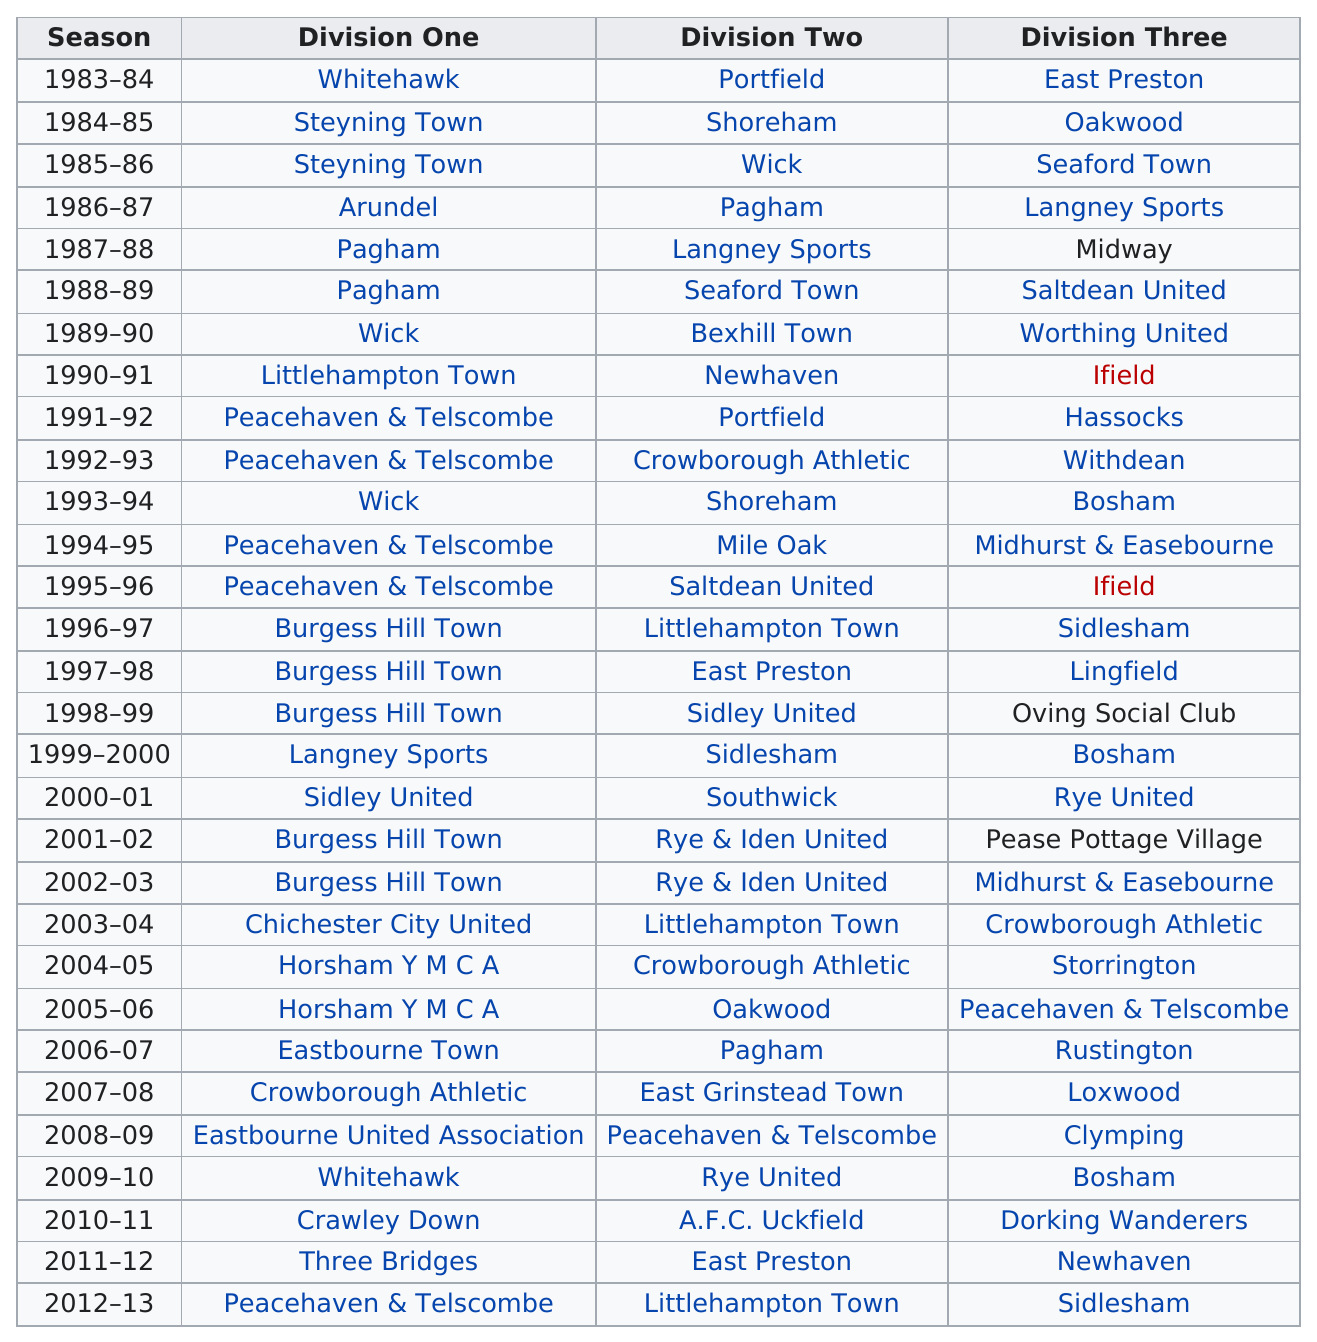Outline some significant characteristics in this image. Seaford Town, a division three team that also played in the division two season during the 1980s, is a historical and intriguing example of a team that has demonstrated versatility and resilience in navigating diverse competitive levels. In the 2000s, Rye and Iden United played each other twice in division two. 